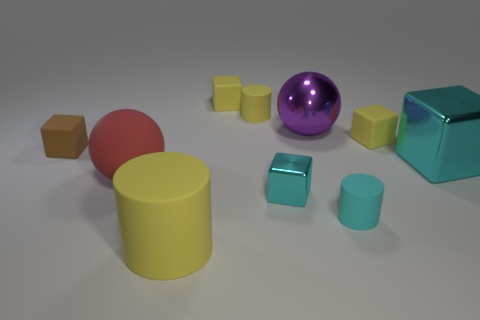Do the purple metallic thing and the brown rubber thing have the same size? no 